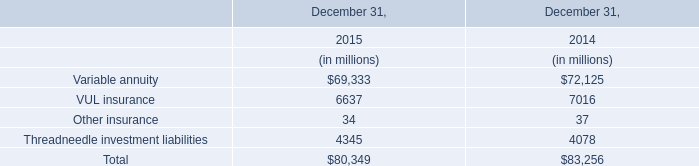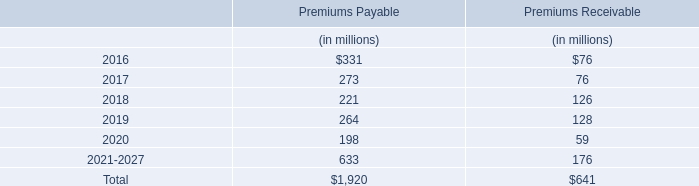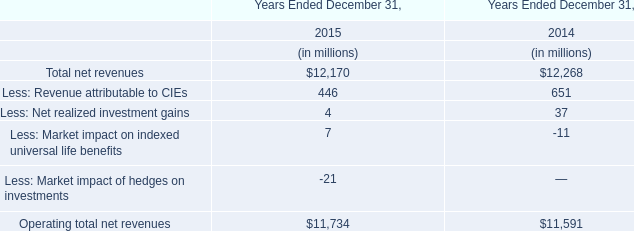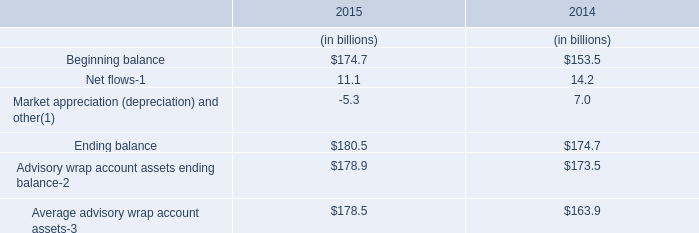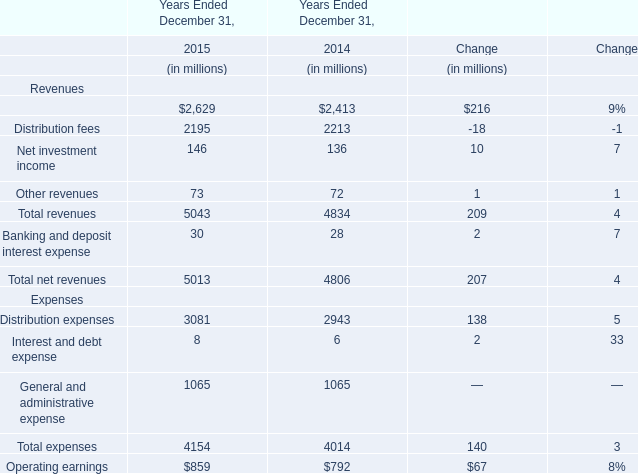What's the average of Beginning balance in 2015 and 2014? (in billion) 
Computations: ((174.7 + 153.5) / 2)
Answer: 164.1. 